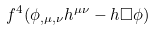Convert formula to latex. <formula><loc_0><loc_0><loc_500><loc_500>f ^ { 4 } ( \phi _ { , \mu , \nu } h ^ { \mu \nu } - h \Box \phi )</formula> 